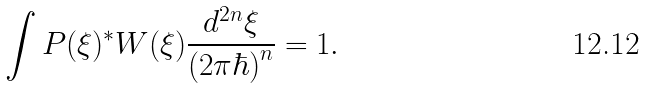<formula> <loc_0><loc_0><loc_500><loc_500>\int { P ( \xi ) ^ { * } W ( \xi ) \frac { d ^ { 2 n } \xi } { ( 2 \pi \hbar { ) } ^ { n } } } = 1 .</formula> 